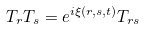Convert formula to latex. <formula><loc_0><loc_0><loc_500><loc_500>T _ { r } T _ { s } = e ^ { i \xi ( r , s , t ) } T _ { r s }</formula> 